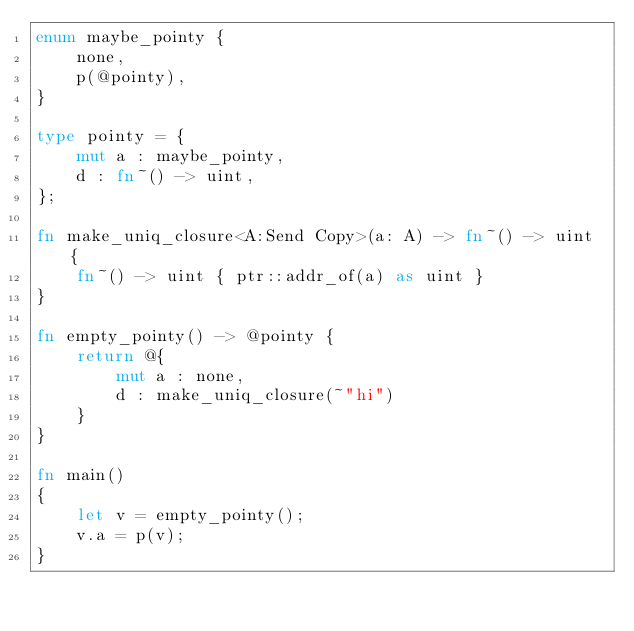Convert code to text. <code><loc_0><loc_0><loc_500><loc_500><_Rust_>enum maybe_pointy {
    none,
    p(@pointy),
}

type pointy = {
    mut a : maybe_pointy,
    d : fn~() -> uint,
};

fn make_uniq_closure<A:Send Copy>(a: A) -> fn~() -> uint {
    fn~() -> uint { ptr::addr_of(a) as uint }
}

fn empty_pointy() -> @pointy {
    return @{
        mut a : none,
        d : make_uniq_closure(~"hi")
    }
}

fn main()
{
    let v = empty_pointy();
    v.a = p(v);
}
</code> 